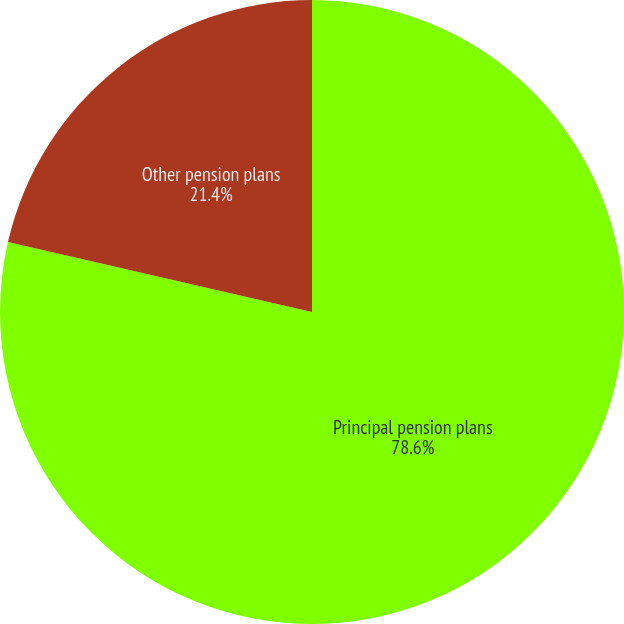Convert chart. <chart><loc_0><loc_0><loc_500><loc_500><pie_chart><fcel>Principal pension plans<fcel>Other pension plans<nl><fcel>78.6%<fcel>21.4%<nl></chart> 